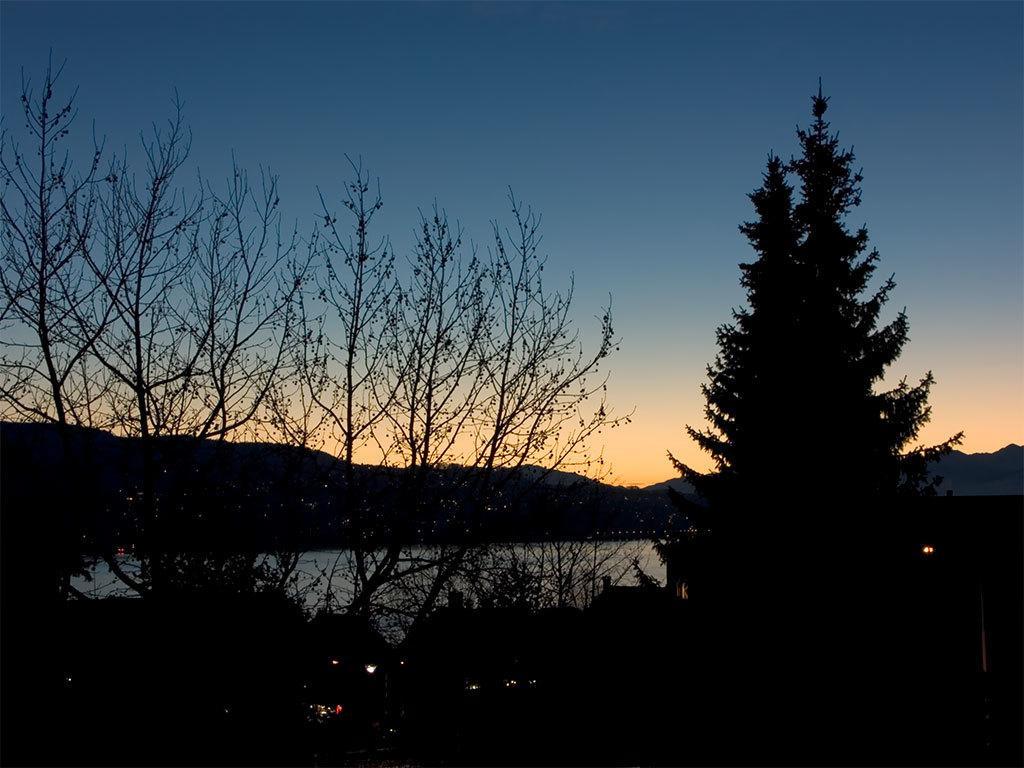Describe this image in one or two sentences. In this image there are trees and there is water and there are lights. 